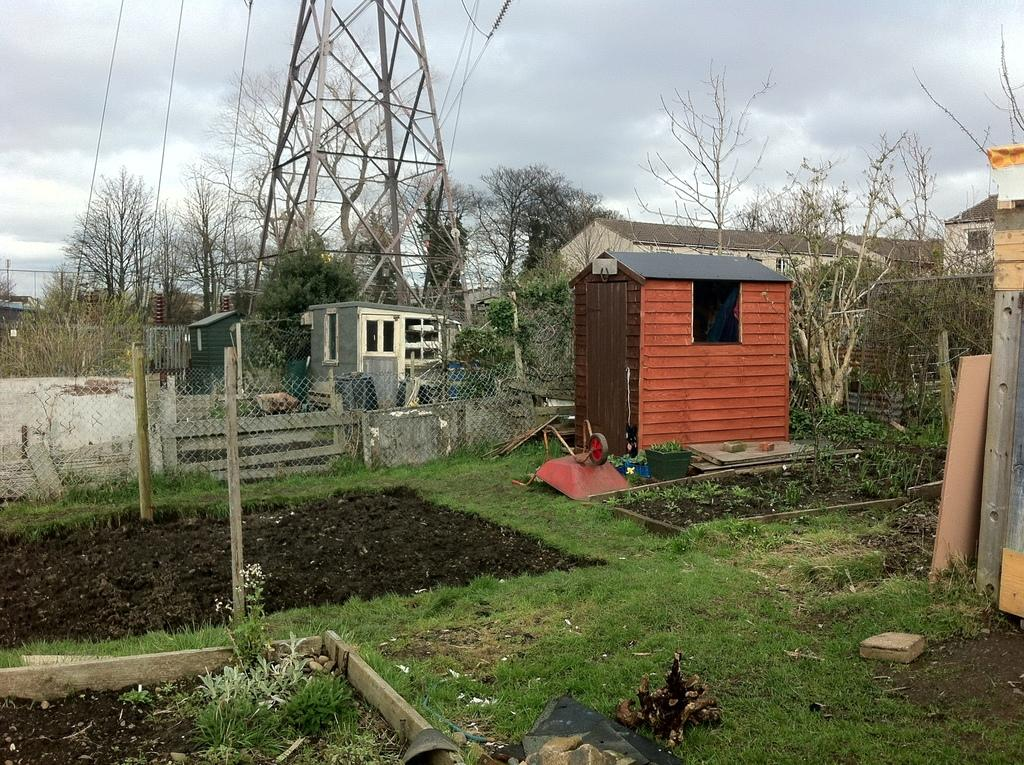What is the tall structure in the image? There is a transmission tower in the image. What is connected to the transmission tower? Electric wires are present in the image. What type of vegetation can be seen in the image? Trees, plants, and grass are visible in the image. What type of buildings are in the image? There are houses in the image. What type of material is used to cover the transmission tower? A mesh is visible in the image. What other structures are present in the image? Poles are present in the image. What is the weather like in the image? The sky is cloudy in the image. What language is spoken by the boats in the image? There are no boats present in the image. What type of government is depicted in the image? There is no government depicted in the image. 